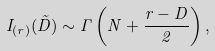<formula> <loc_0><loc_0><loc_500><loc_500>I _ { ( r ) } ( \tilde { D } ) \sim \Gamma \left ( N + \frac { r - D } { 2 } \right ) ,</formula> 